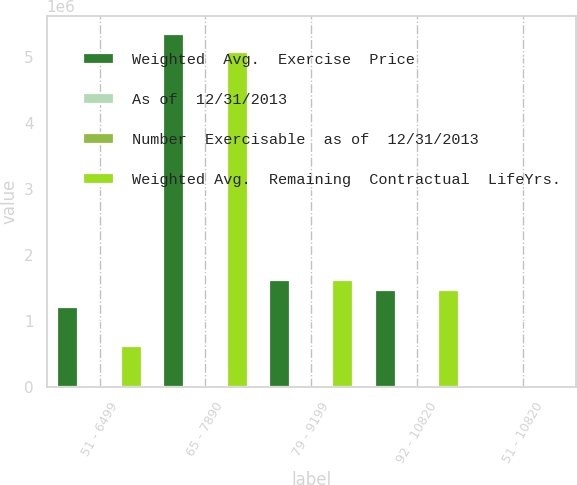Convert chart. <chart><loc_0><loc_0><loc_500><loc_500><stacked_bar_chart><ecel><fcel>51 - 6499<fcel>65 - 7890<fcel>79 - 9199<fcel>92 - 10820<fcel>51 - 10820<nl><fcel>Weighted  Avg.  Exercise  Price<fcel>1.20558e+06<fcel>5.34185e+06<fcel>1.62182e+06<fcel>1.4706e+06<fcel>100.01<nl><fcel>As of  12/31/2013<fcel>0.6<fcel>5.3<fcel>4.1<fcel>5.1<fcel>4.5<nl><fcel>Number  Exercisable  as of  12/31/2013<fcel>61.55<fcel>72.91<fcel>91.82<fcel>108.2<fcel>80.06<nl><fcel>Weighted Avg.  Remaining  Contractual  LifeYrs.<fcel>613481<fcel>5.07626e+06<fcel>1.62182e+06<fcel>1.4706e+06<fcel>100.01<nl></chart> 